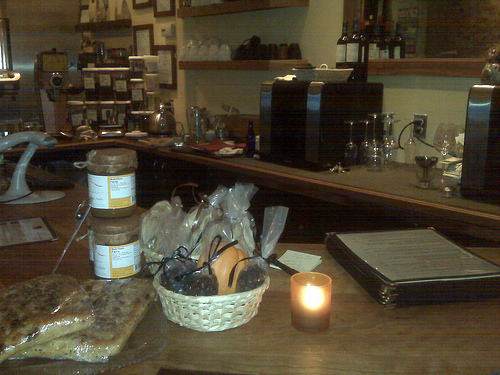<image>
Can you confirm if the baked goods is above the baked goods? No. The baked goods is not positioned above the baked goods. The vertical arrangement shows a different relationship. 